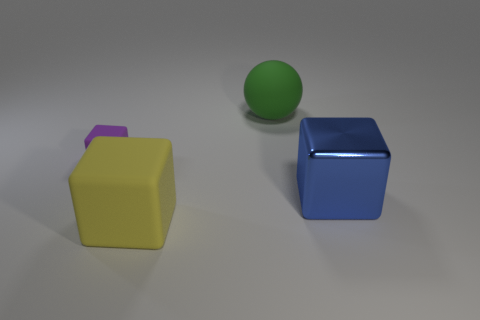The rubber thing behind the block that is behind the blue cube is what color?
Provide a succinct answer. Green. How many big red metal cylinders are there?
Provide a short and direct response. 0. Is the color of the large rubber ball the same as the large shiny block?
Your answer should be very brief. No. Is the number of matte blocks that are on the left side of the yellow object less than the number of yellow cubes behind the green matte ball?
Your answer should be very brief. No. What is the color of the big shiny cube?
Give a very brief answer. Blue. What number of metallic blocks have the same color as the metallic thing?
Make the answer very short. 0. There is a large yellow thing; are there any purple cubes in front of it?
Offer a very short reply. No. Are there the same number of matte blocks that are behind the purple object and big matte blocks that are in front of the blue thing?
Offer a terse response. No. There is a cube on the right side of the large matte sphere; does it have the same size as the matte cube left of the yellow matte object?
Keep it short and to the point. No. There is a rubber object behind the rubber cube that is left of the big matte thing that is on the left side of the big rubber sphere; what shape is it?
Your answer should be very brief. Sphere. 